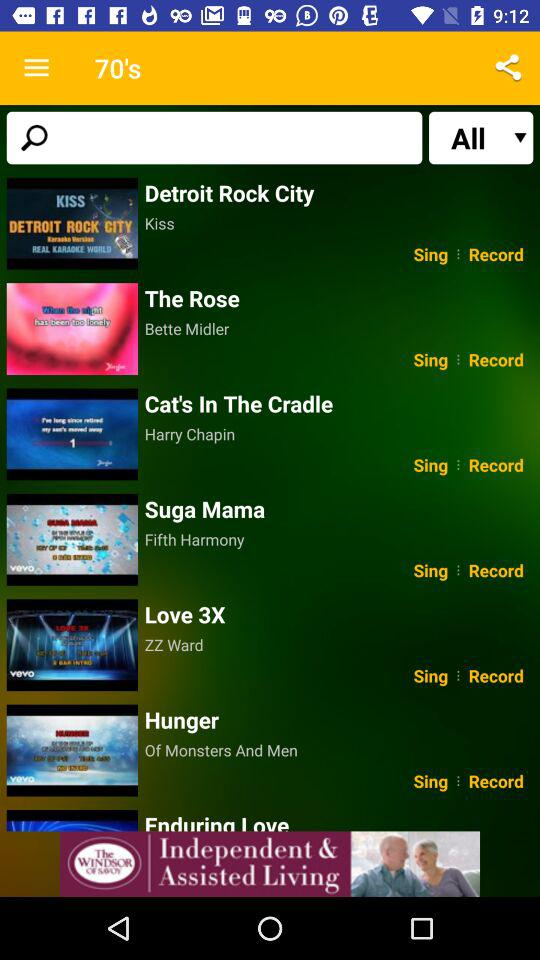What song is by Harry Chapin? The song is "Cat's In The Cradle". 